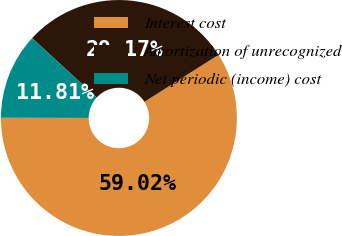<chart> <loc_0><loc_0><loc_500><loc_500><pie_chart><fcel>Interest cost<fcel>Amortization of unrecognized<fcel>Net periodic (income) cost<nl><fcel>59.03%<fcel>29.17%<fcel>11.81%<nl></chart> 